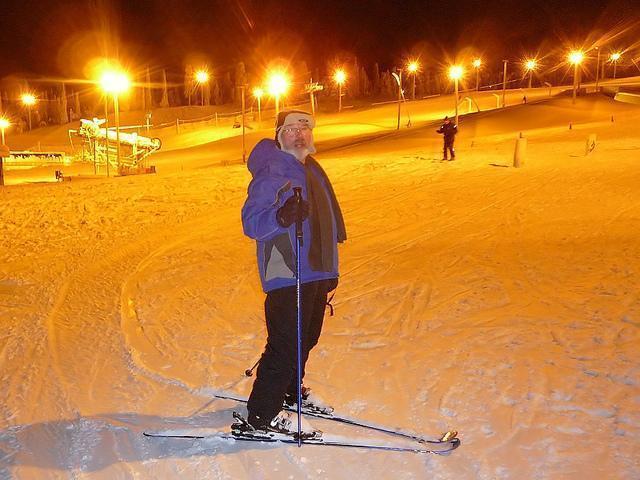Why is the man wearing a hat with earflaps?
Choose the correct response, then elucidate: 'Answer: answer
Rationale: rationale.'
Options: Warmth, visibility, as cosplay, fashion. Answer: warmth.
Rationale: When skiing in the snow and cold the ears need to be protected from frostbite. 